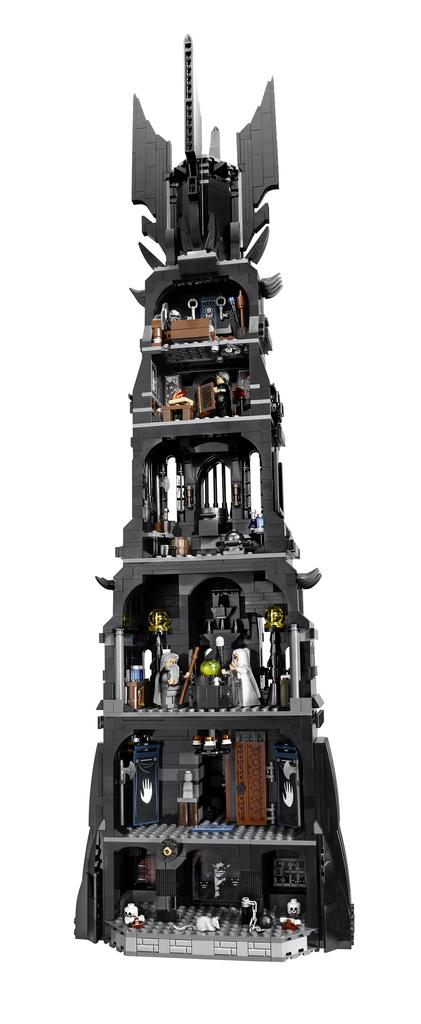What object can be seen in the picture? There is a toy in the picture. What is the color of the toy? The toy is black in color. What color is the background of the image? The background of the image is white. Where can the flowers be found in the image? There are no flowers present in the image. 